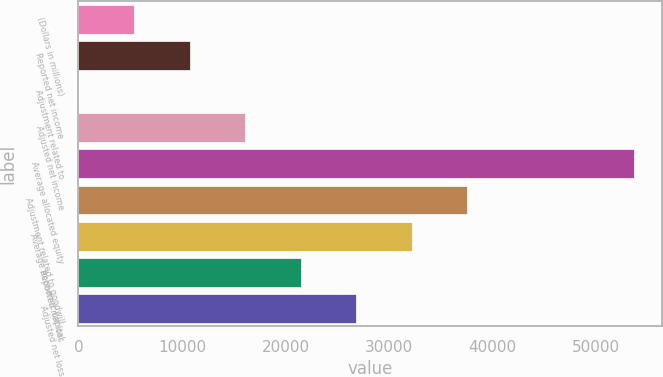<chart> <loc_0><loc_0><loc_500><loc_500><bar_chart><fcel>(Dollars in millions)<fcel>Reported net income<fcel>Adjustment related to<fcel>Adjusted net income<fcel>Average allocated equity<fcel>Adjustment related to goodwill<fcel>Average economic capital<fcel>Reported net loss<fcel>Adjusted net loss<nl><fcel>5376.3<fcel>10739.6<fcel>13<fcel>16102.9<fcel>53646<fcel>37556.1<fcel>32192.8<fcel>21466.2<fcel>26829.5<nl></chart> 